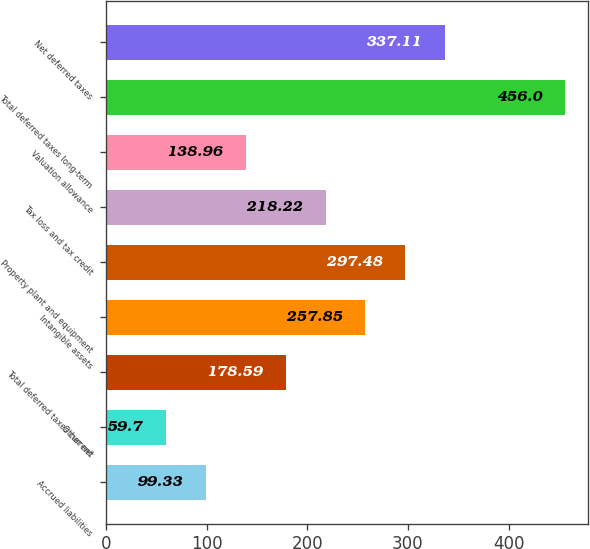Convert chart. <chart><loc_0><loc_0><loc_500><loc_500><bar_chart><fcel>Accrued liabilities<fcel>Other net<fcel>Total deferred taxes current<fcel>Intangible assets<fcel>Property plant and equipment<fcel>Tax loss and tax credit<fcel>Valuation allowance<fcel>Total deferred taxes long-term<fcel>Net deferred taxes<nl><fcel>99.33<fcel>59.7<fcel>178.59<fcel>257.85<fcel>297.48<fcel>218.22<fcel>138.96<fcel>456<fcel>337.11<nl></chart> 